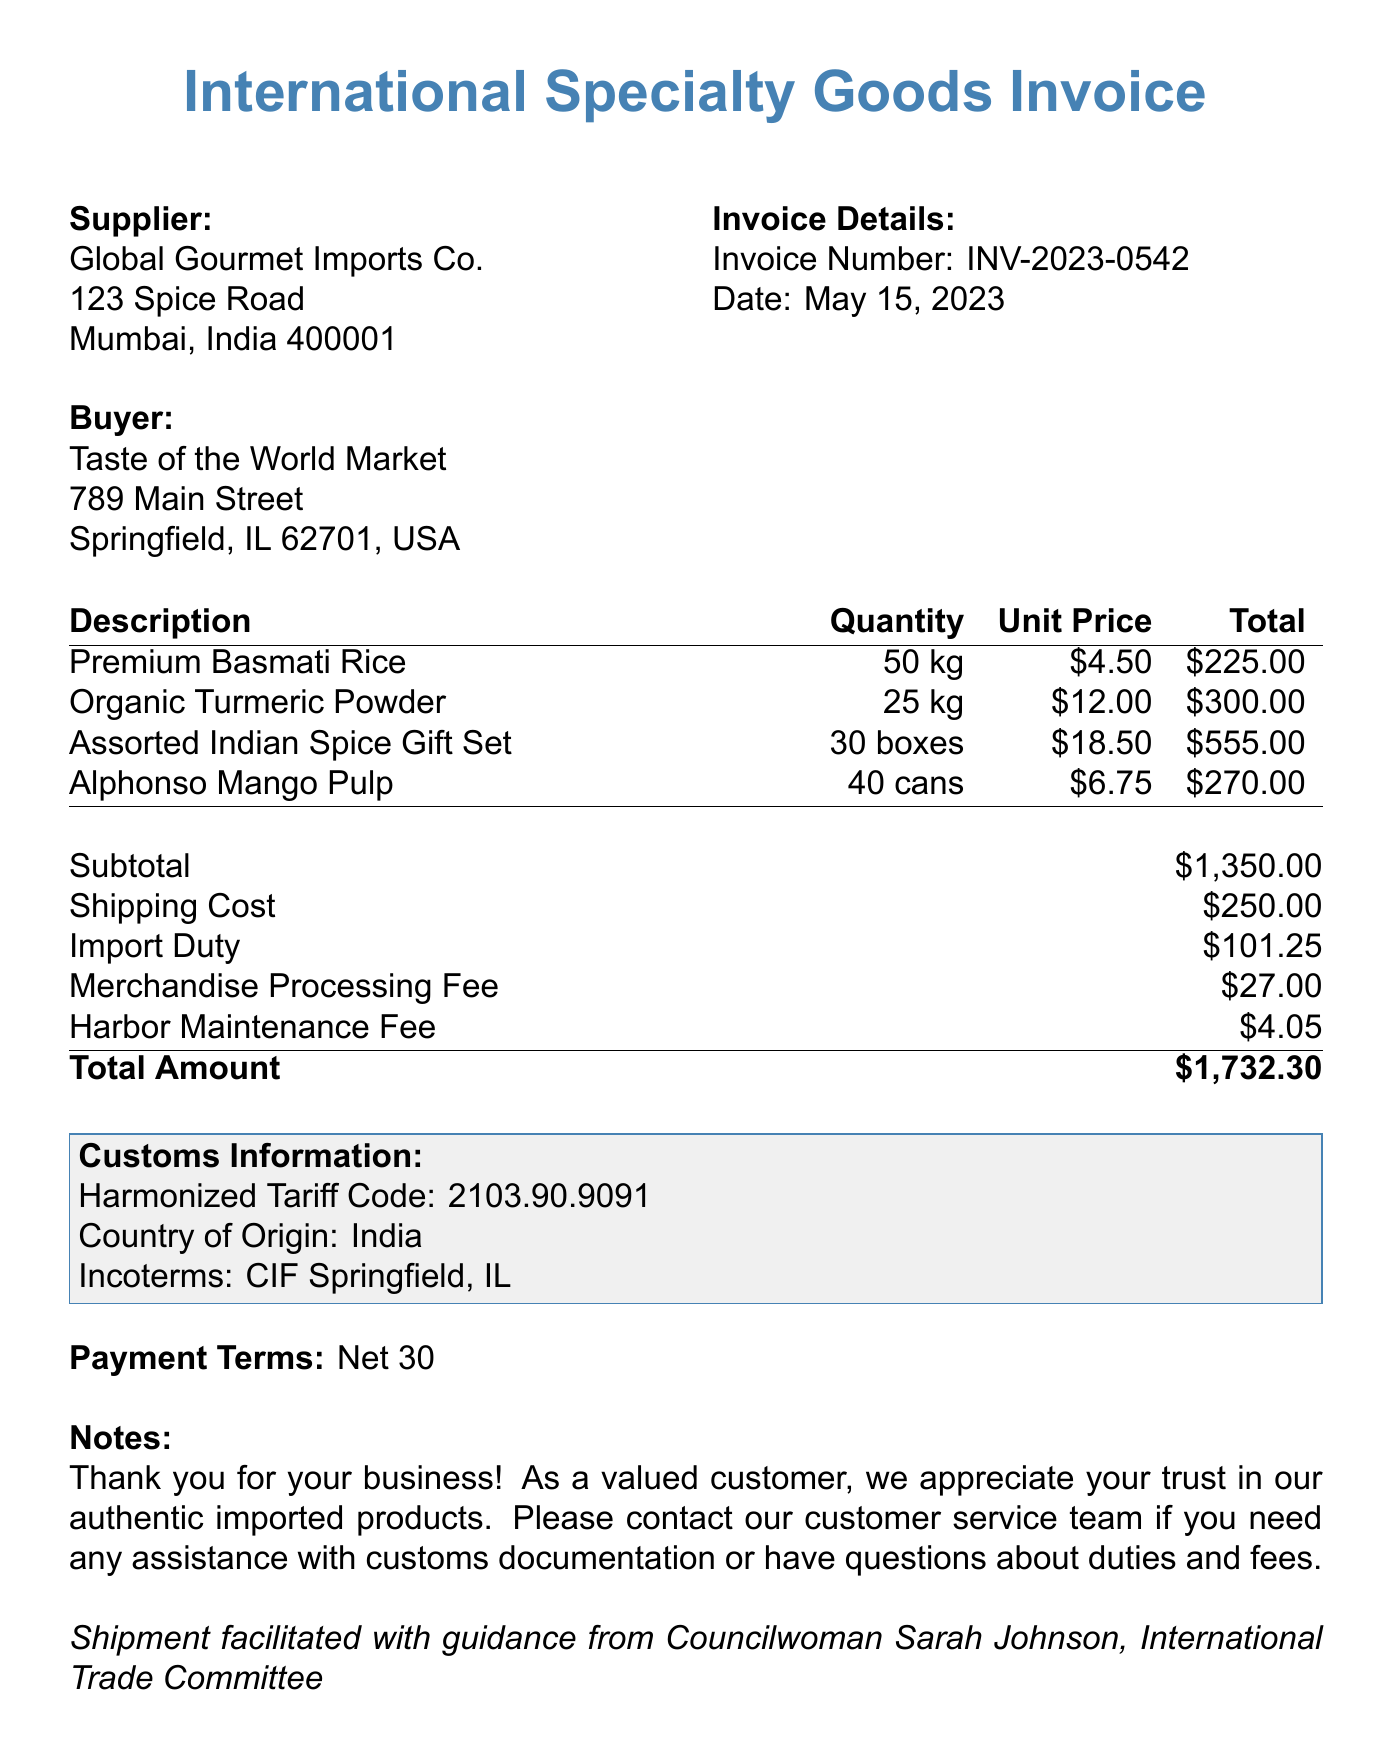What is the invoice number? The invoice number is provided at the top of the document, which identifies this particular invoice.
Answer: INV-2023-0542 What is the date of the invoice? The date when the invoice was issued is specified in the document under the invoice details.
Answer: May 15, 2023 Who is the supplier of the goods? The supplier's name is listed in the document as part of the invoice details.
Answer: Global Gourmet Imports Co What is the subtotal amount? The subtotal amount is given in the invoice before additional fees and charges.
Answer: $1,350.00 How many kilograms of Premium Basmati Rice were purchased? The quantity of Premium Basmati Rice is specified in the item list of the invoice.
Answer: 50 kg What are the total customs fees? Total customs fees are itemized and summed in the document to reflect the total charged for customs.
Answer: $132.30 What are the payment terms listed in the invoice? Payment terms are mentioned towards the end of the document, outlining the conditions for payment.
Answer: Net 30 Who facilitated the shipment? The document includes a note about the person who assisted with the shipment process.
Answer: Councilwoman Sarah Johnson 